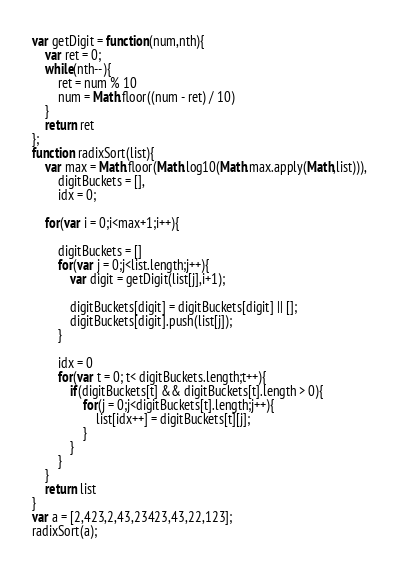<code> <loc_0><loc_0><loc_500><loc_500><_JavaScript_>var getDigit = function(num,nth){
    var ret = 0;
    while(nth--){
        ret = num % 10
        num = Math.floor((num - ret) / 10)
    }
    return ret
};
function radixSort(list){
    var max = Math.floor(Math.log10(Math.max.apply(Math,list))),
        digitBuckets = [],
        idx = 0;

    for(var i = 0;i<max+1;i++){

        digitBuckets = []
        for(var j = 0;j<list.length;j++){
            var digit = getDigit(list[j],i+1);

            digitBuckets[digit] = digitBuckets[digit] || [];
            digitBuckets[digit].push(list[j]);
        }

        idx = 0
        for(var t = 0; t< digitBuckets.length;t++){
            if(digitBuckets[t] && digitBuckets[t].length > 0){
                for(j = 0;j<digitBuckets[t].length;j++){
                    list[idx++] = digitBuckets[t][j];
                }
            }
        }
    }
    return list
}
var a = [2,423,2,43,23423,43,22,123];
radixSort(a);
</code> 